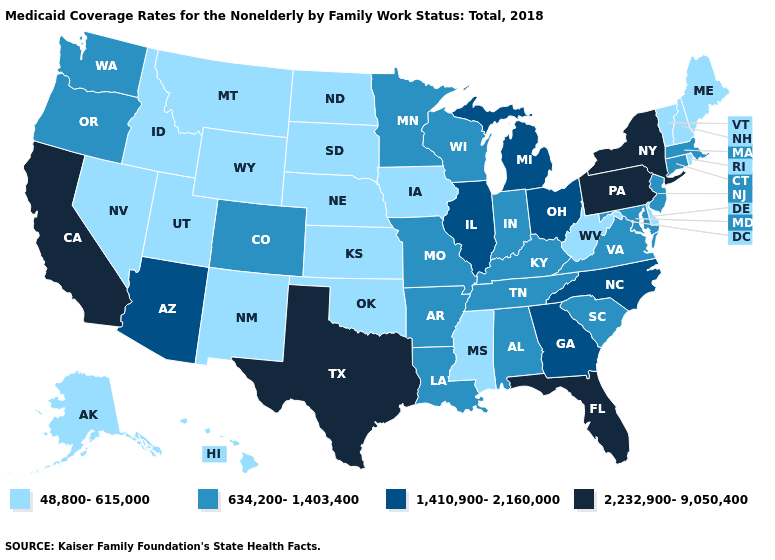Among the states that border Idaho , which have the highest value?
Answer briefly. Oregon, Washington. Which states have the lowest value in the USA?
Write a very short answer. Alaska, Delaware, Hawaii, Idaho, Iowa, Kansas, Maine, Mississippi, Montana, Nebraska, Nevada, New Hampshire, New Mexico, North Dakota, Oklahoma, Rhode Island, South Dakota, Utah, Vermont, West Virginia, Wyoming. What is the lowest value in the USA?
Write a very short answer. 48,800-615,000. Name the states that have a value in the range 1,410,900-2,160,000?
Write a very short answer. Arizona, Georgia, Illinois, Michigan, North Carolina, Ohio. Does Oregon have a higher value than Minnesota?
Short answer required. No. Which states hav the highest value in the Northeast?
Quick response, please. New York, Pennsylvania. What is the value of Maine?
Be succinct. 48,800-615,000. Name the states that have a value in the range 2,232,900-9,050,400?
Give a very brief answer. California, Florida, New York, Pennsylvania, Texas. What is the value of New York?
Write a very short answer. 2,232,900-9,050,400. Name the states that have a value in the range 2,232,900-9,050,400?
Keep it brief. California, Florida, New York, Pennsylvania, Texas. Does the first symbol in the legend represent the smallest category?
Answer briefly. Yes. Which states hav the highest value in the MidWest?
Answer briefly. Illinois, Michigan, Ohio. What is the value of Indiana?
Concise answer only. 634,200-1,403,400. Name the states that have a value in the range 1,410,900-2,160,000?
Keep it brief. Arizona, Georgia, Illinois, Michigan, North Carolina, Ohio. Does Illinois have the highest value in the MidWest?
Be succinct. Yes. 